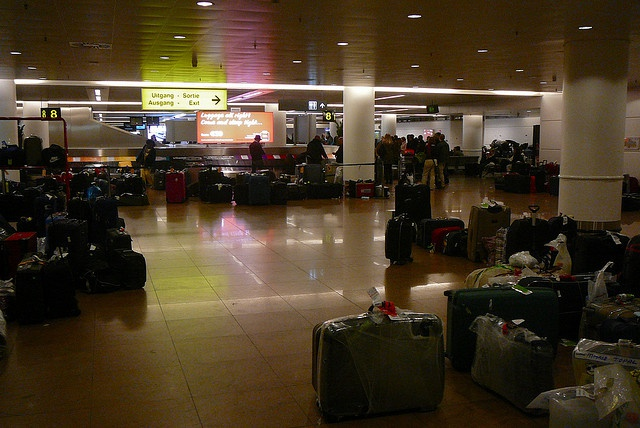Describe the objects in this image and their specific colors. I can see suitcase in black, darkgreen, maroon, and gray tones, suitcase in black, maroon, darkgreen, and gray tones, suitcase in black, maroon, darkgreen, and gray tones, suitcase in black, darkgreen, gray, and maroon tones, and suitcase in black, tan, and gray tones in this image. 